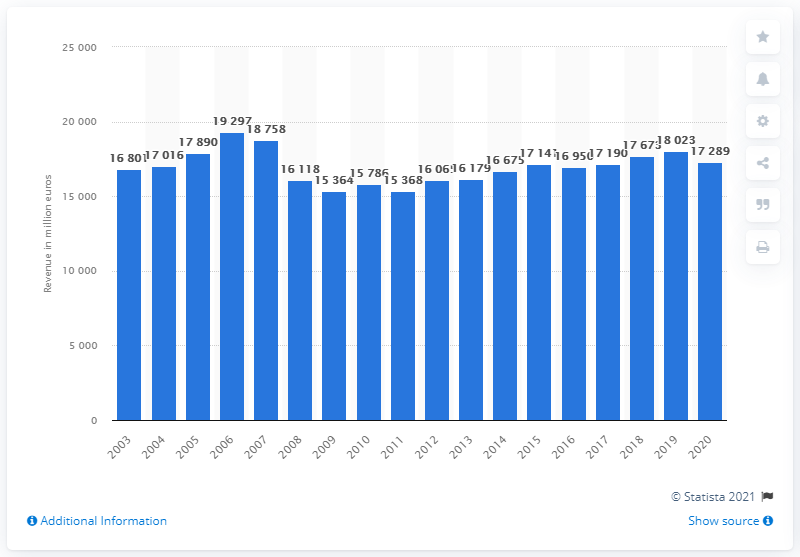Mention a couple of crucial points in this snapshot. In 2007, the revenue of Bertelsmann SE & Co. KGaA was the highest it has ever been. The revenue of Bertelsmann SE & Co. KGaA in the previous year was approximately 18,023. In 2020, the total revenue of Bertelsmann SE & Co. KGaA was 17,289. 